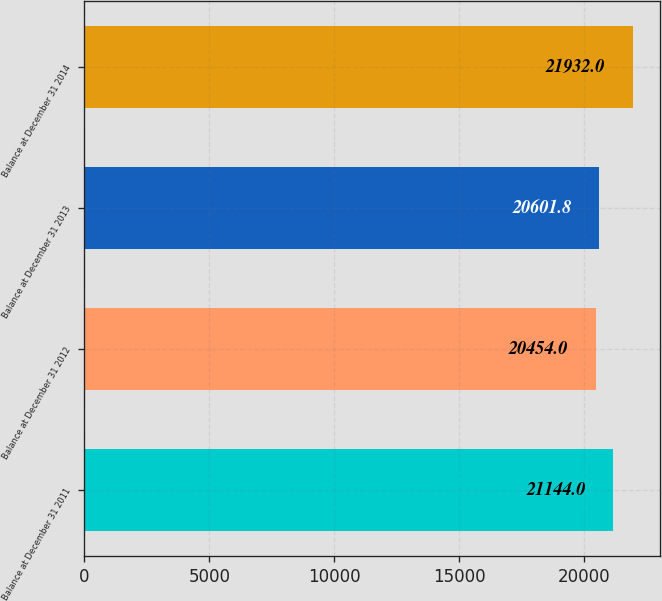<chart> <loc_0><loc_0><loc_500><loc_500><bar_chart><fcel>Balance at December 31 2011<fcel>Balance at December 31 2012<fcel>Balance at December 31 2013<fcel>Balance at December 31 2014<nl><fcel>21144<fcel>20454<fcel>20601.8<fcel>21932<nl></chart> 